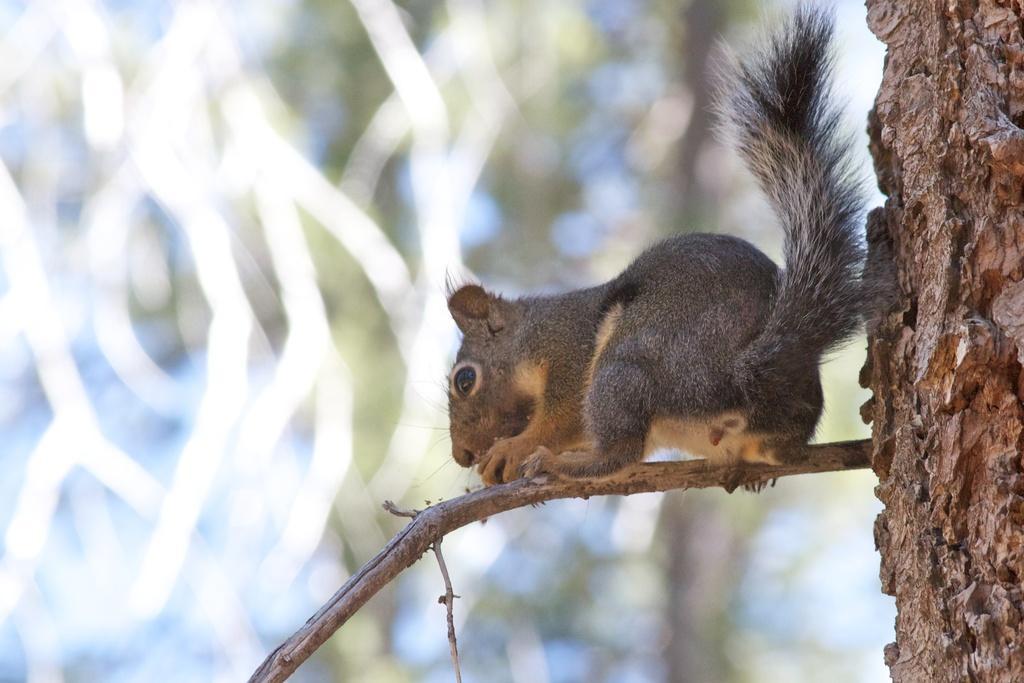In one or two sentences, can you explain what this image depicts? In this image we can see a squirrel on the branch of a tree. 